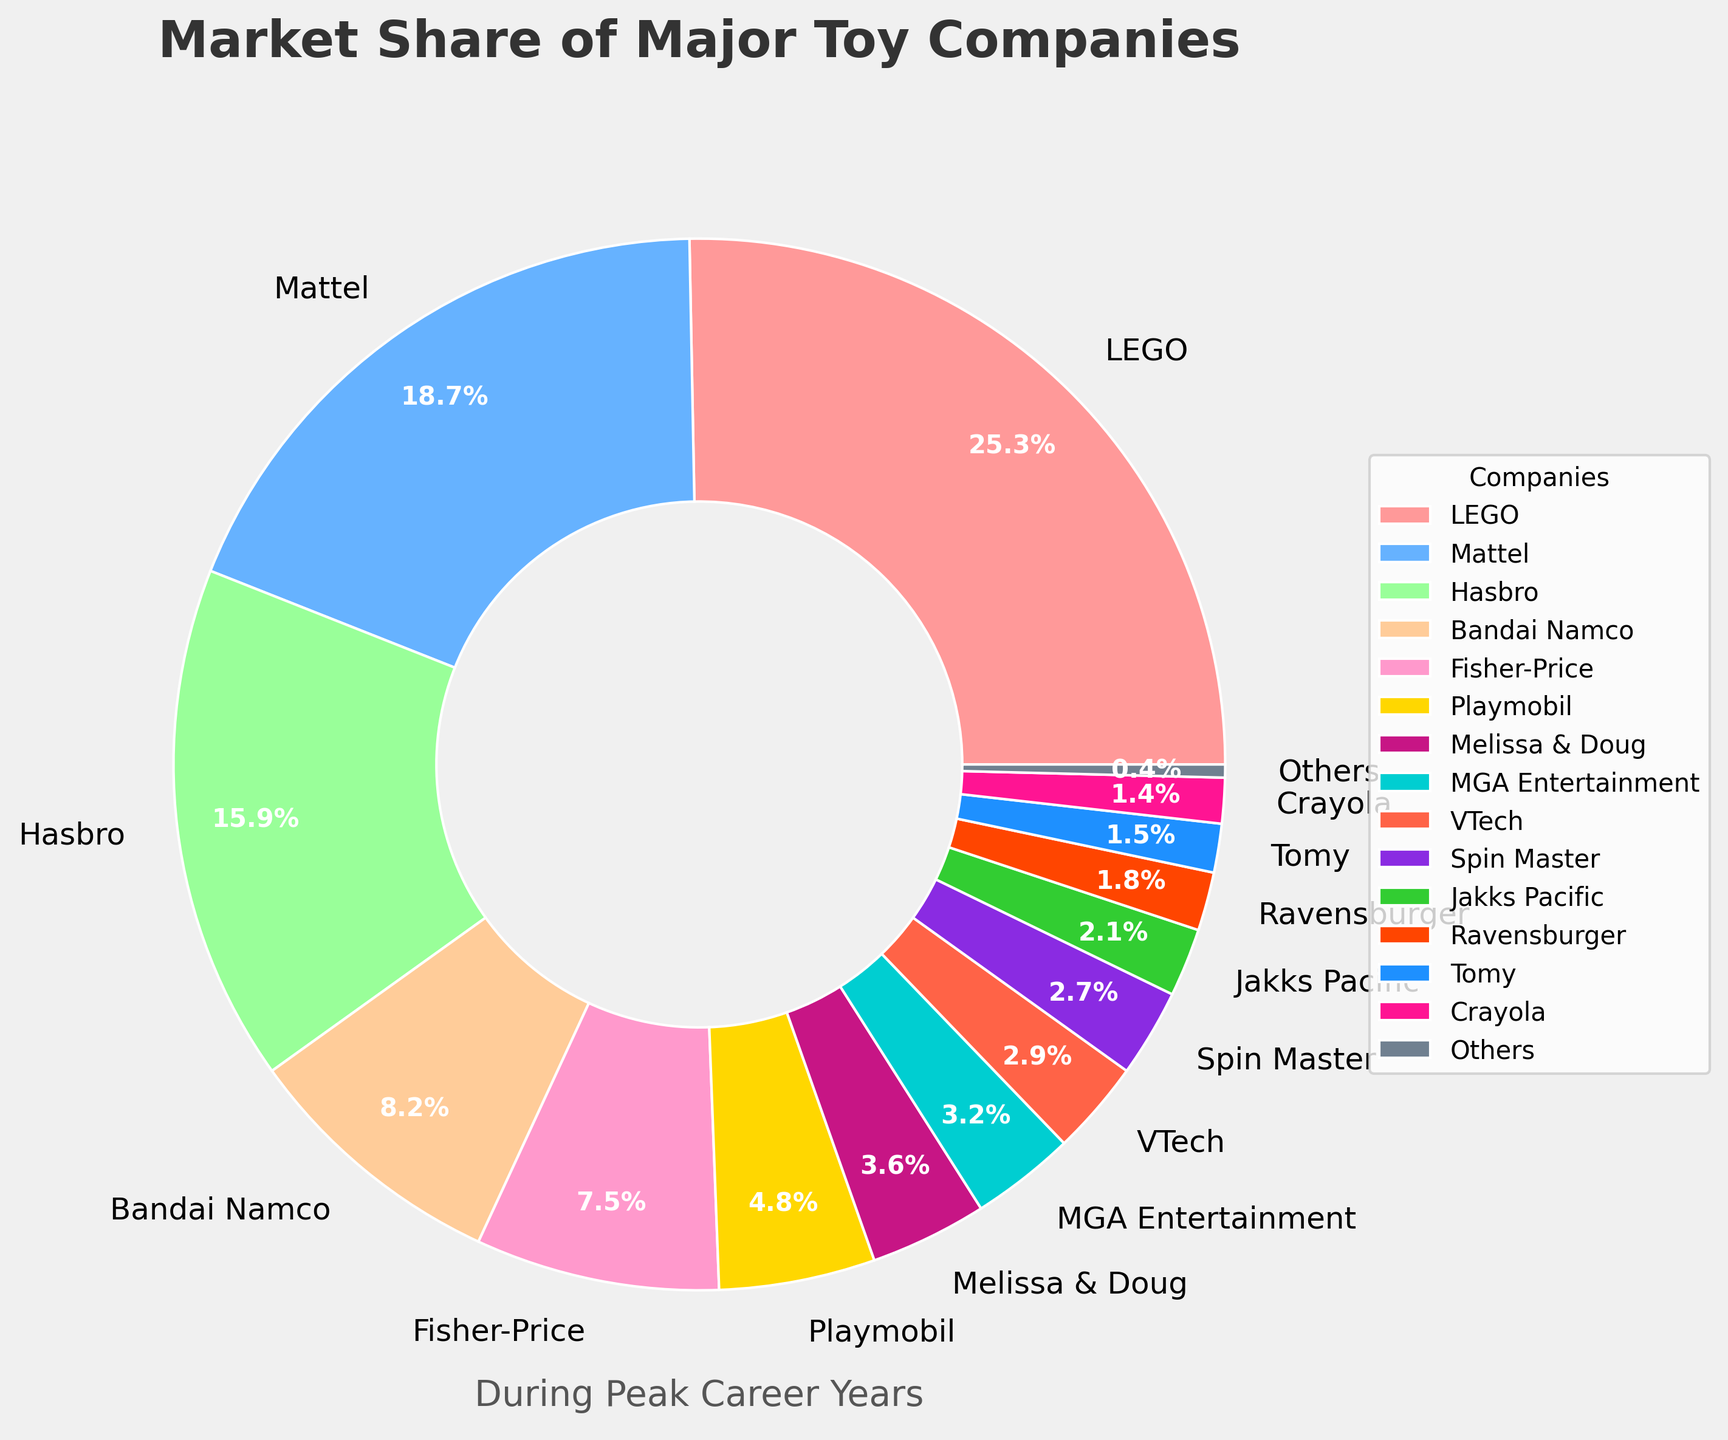What company has the largest market share? By looking at the pie chart, the company with the largest segment will have the largest market share. That company is LEGO.
Answer: LEGO Which company has a market share smaller than 5% but larger than 3%? By inspecting the pie chart, we find the company segments whose percentages fall between 3% and 5%. These companies are Playmobil, Melissa & Doug, and MGA Entertainment.
Answer: Playmobil, Melissa & Doug, MGA Entertainment How much more market share does LEGO have compared to Hasbro? To find the market share difference between LEGO and Hasbro, we subtract Hasbro's percentage from LEGO's. 25.3% - 15.9% = 9.4%
Answer: 9.4% What's the total market share of the top three companies? Sum the market shares of LEGO, Mattel, and Hasbro. 25.3% + 18.7% + 15.9% = 59.9%
Answer: 59.9% Which company has a visually distinct pink-colored segment, and what is its market share? The legend or labels in the pie chart must be checked for the pink-colored segment. This segment belongs to Fisher-Price, with a market share of 7.5%.
Answer: Fisher-Price, 7.5% Are there any companies with a market share less than 2%? By checking the pie chart for the smallest segments, we find that Tomy, Crayola, and Others all have market shares less than 2%.
Answer: Tomy, Crayola, Others What's the combined market share of companies with exactly 2 significant figures? Sum the market shares of Bandai Namco (8.2%), Fisher-Price (7.5%), and Spin Master (2.7%). 8.2% + 7.5% + 2.7% = 18.4%
Answer: 18.4% Subtract the market share of Ravensburger from VTech. To find the difference between the market shares of VTech and Ravensburger, subtract Ravensburger's percentage from VTech's. 2.9% - 1.8% = 1.1%
Answer: 1.1% Which color represents Mattel, and what is the company’s market share? By referencing the pie chart and its legend or labels, Mattel is represented by the light blue segment with a market share of 18.7%.
Answer: Light blue, 18.7% Calculate the average market share of Fisher-Price, Playmobil, and Melissa & Doug. Add the market shares and divide by 3: (7.5% + 4.8% + 3.6%) / 3 = 15.9% / 3 = 5.3%
Answer: 5.3% 